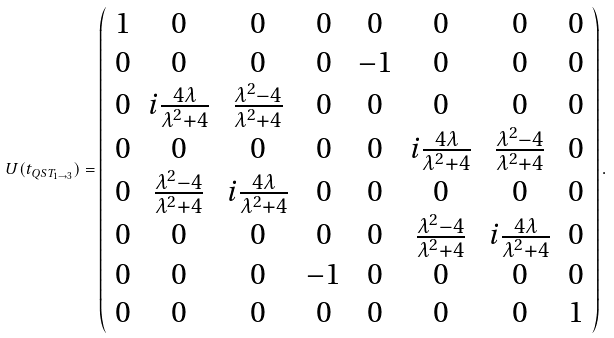<formula> <loc_0><loc_0><loc_500><loc_500>U ( t _ { Q S T _ { 1 \rightarrow 3 } } ) = \left ( \begin{array} { c c c c c c c c } 1 & 0 & 0 & 0 & 0 & 0 & 0 & 0 \\ 0 & 0 & 0 & 0 & - 1 & 0 & 0 & 0 \\ 0 & i \frac { 4 \lambda } { \lambda ^ { 2 } + 4 } & \frac { \lambda ^ { 2 } - 4 } { \lambda ^ { 2 } + 4 } & 0 & 0 & 0 & 0 & 0 \\ 0 & 0 & 0 & 0 & 0 & i \frac { 4 \lambda } { \lambda ^ { 2 } + 4 } & \frac { \lambda ^ { 2 } - 4 } { \lambda ^ { 2 } + 4 } & 0 \\ 0 & \frac { \lambda ^ { 2 } - 4 } { \lambda ^ { 2 } + 4 } & i \frac { 4 \lambda } { \lambda ^ { 2 } + 4 } & 0 & 0 & 0 & 0 & 0 \\ 0 & 0 & 0 & 0 & 0 & \frac { \lambda ^ { 2 } - 4 } { \lambda ^ { 2 } + 4 } & i \frac { 4 \lambda } { \lambda ^ { 2 } + 4 } & 0 \\ 0 & 0 & 0 & - 1 & 0 & 0 & 0 & 0 \\ 0 & 0 & 0 & 0 & 0 & 0 & 0 & 1 \\ \end{array} \right ) .</formula> 